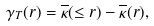Convert formula to latex. <formula><loc_0><loc_0><loc_500><loc_500>\gamma _ { T } ( r ) = \overline { \kappa } ( \leq r ) - \overline { \kappa } ( r ) ,</formula> 